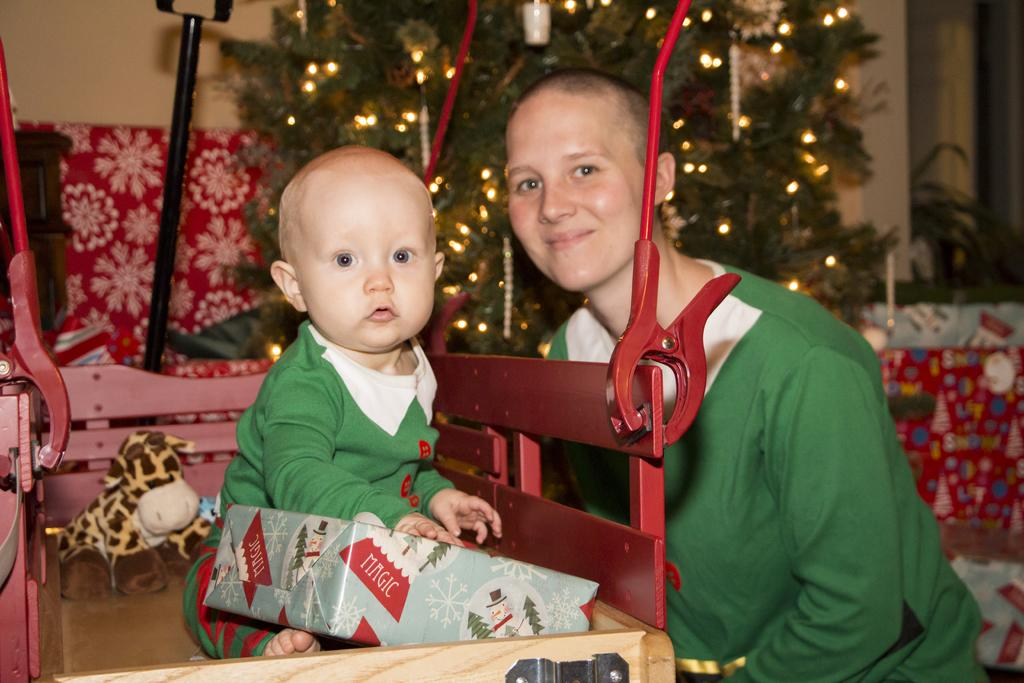How many people are in the image? There are two persons in the image. What is the baby wearing? The baby is wearing a green dress. What is the baby holding? The baby is holding a box. What can be seen in the background of the image? There is a tree, a pole, and a doll placed on a table in the background of the image. How many ducks are sitting on the baby's head in the image? There are no ducks visible in the image. 